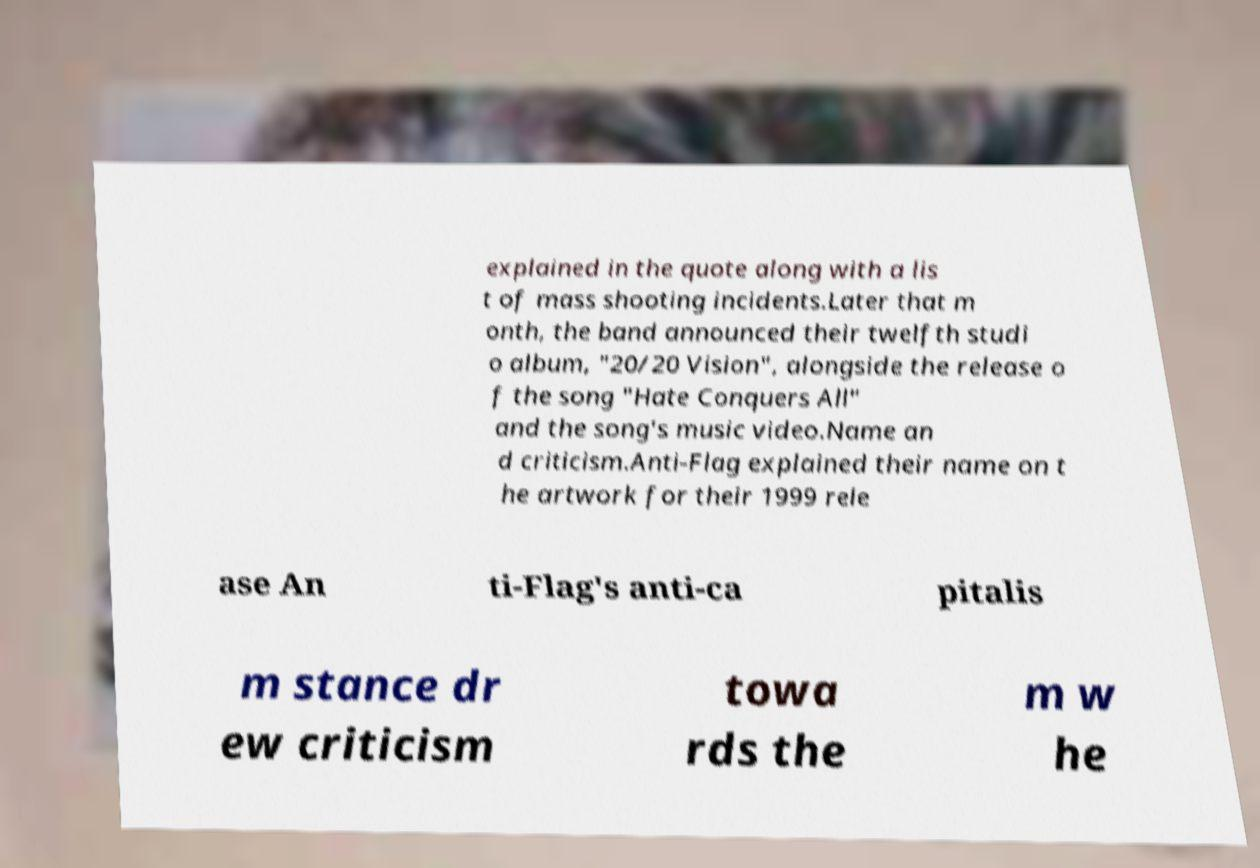What messages or text are displayed in this image? I need them in a readable, typed format. explained in the quote along with a lis t of mass shooting incidents.Later that m onth, the band announced their twelfth studi o album, "20/20 Vision", alongside the release o f the song "Hate Conquers All" and the song's music video.Name an d criticism.Anti-Flag explained their name on t he artwork for their 1999 rele ase An ti-Flag's anti-ca pitalis m stance dr ew criticism towa rds the m w he 